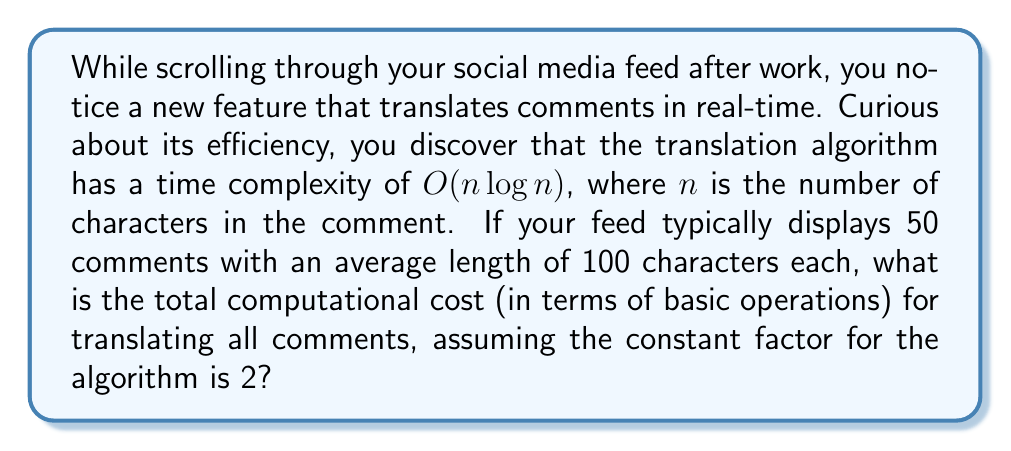Teach me how to tackle this problem. Let's break this down step-by-step:

1) The time complexity of the translation algorithm is $O(n \log n)$, where $n$ is the number of characters.

2) We're given that the constant factor is 2, so the actual number of operations for each comment is:

   $2n \log n$

3) Each comment has an average of 100 characters, so for a single comment:

   $n = 100$
   Operations = $2 * 100 * \log 100$

4) To calculate this:
   $\log 100 \approx 6.64386$ (using base-2 logarithm)
   
   $2 * 100 * 6.64386 \approx 1,328.772$ operations

5) There are 50 comments in total, so we multiply this by 50:

   $1,328.772 * 50 \approx 66,438.6$ operations

6) Rounding to the nearest whole number (as we can't have partial operations):

   $66,439$ operations

This represents the total computational cost for translating all comments in your feed.
Answer: 66,439 operations 